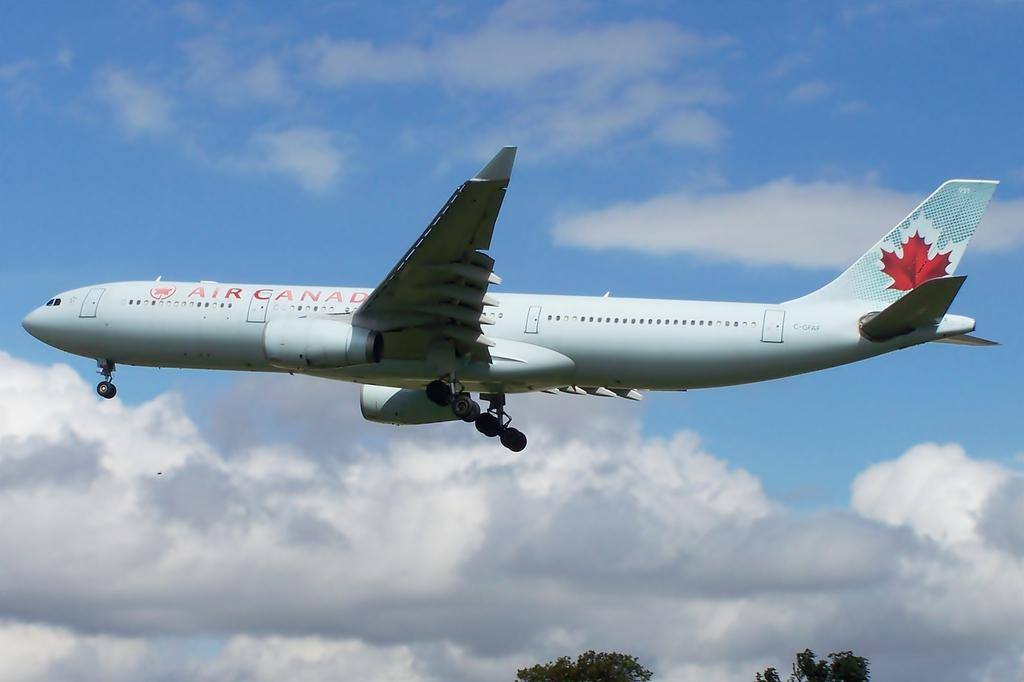What type of vegetation is at the bottom of the image? There are trees at the bottom of the image. What is the main subject in the middle of the image? There is a plane in the middle of the image. What can be seen behind the plane in the image? There are clouds visible behind the plane. What is visible in the background of the image? The sky is visible in the image. What type of wood is used to build the plane in the image? There is no mention of wood or any building materials in the image; it features a plane in the sky. How does the love between the trees and the clouds manifest in the image? There is no indication of love or any emotional connection between the trees and clouds in the image. 